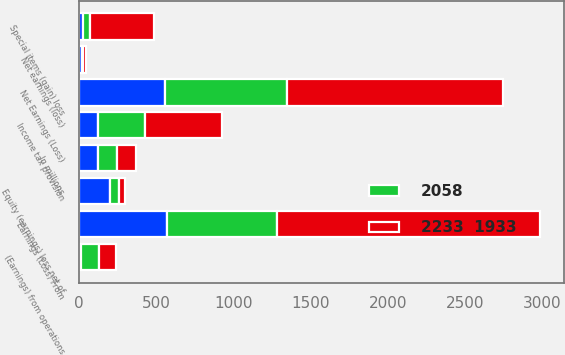Convert chart to OTSL. <chart><loc_0><loc_0><loc_500><loc_500><stacked_bar_chart><ecel><fcel>In millions<fcel>Net Earnings (Loss)<fcel>(Earnings) from operations<fcel>Special items (gain) loss<fcel>Earnings (Loss) From<fcel>Income tax provision<fcel>Equity (earnings) loss net of<fcel>Net earnings (loss)<nl><fcel>nan<fcel>123<fcel>555<fcel>11<fcel>24<fcel>568<fcel>123<fcel>200<fcel>19<nl><fcel>2233  1933<fcel>123<fcel>1395<fcel>109<fcel>418<fcel>1704<fcel>498<fcel>39<fcel>17<nl><fcel>2058<fcel>123<fcel>794<fcel>120<fcel>43<fcel>717<fcel>306<fcel>61<fcel>5<nl></chart> 